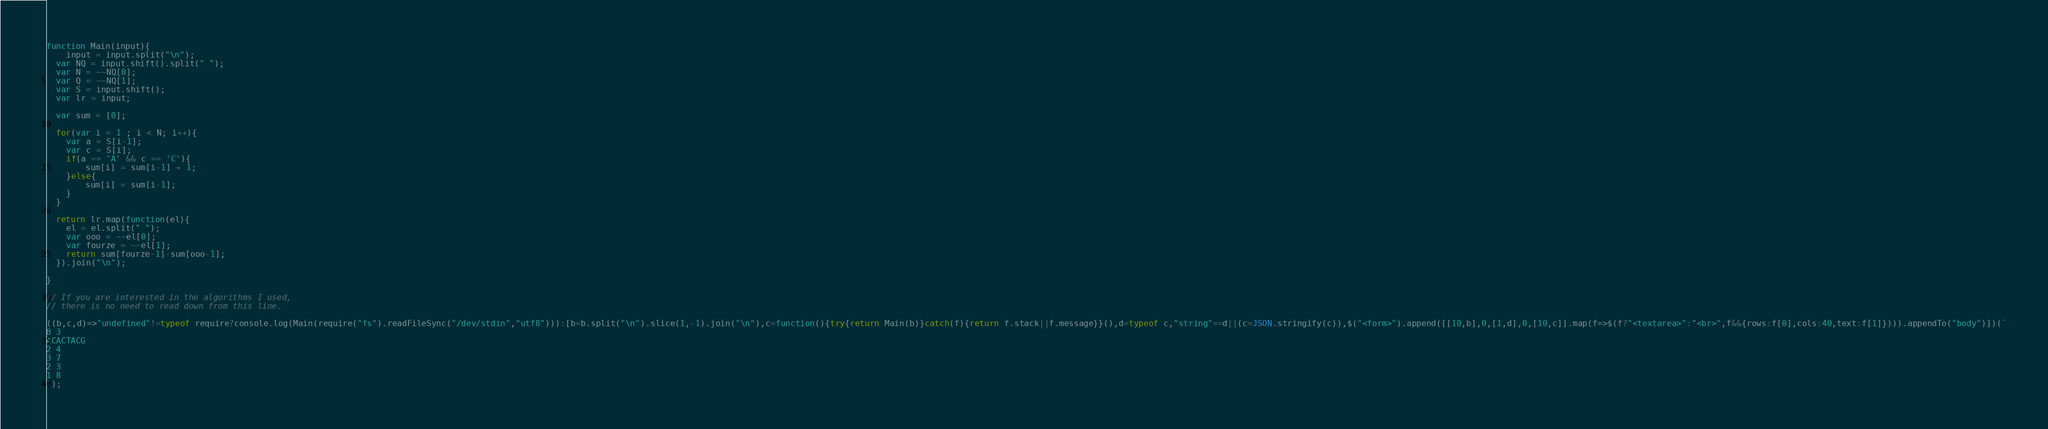Convert code to text. <code><loc_0><loc_0><loc_500><loc_500><_JavaScript_>function Main(input){
	input = input.split("\n");
  var NQ = input.shift().split(" ");
  var N = ~~NQ[0];
  var Q = ~~NQ[1];
  var S = input.shift();
  var lr = input;
  
  var sum = [0];
  
  for(var i = 1 ; i < N; i++){
  	var a = S[i-1];
    var c = S[i];
    if(a == 'A' && c == 'C'){
    	sum[i] = sum[i-1] + 1;
    }else{
    	sum[i] = sum[i-1];
    }
  }
  
  return lr.map(function(el){
  	el = el.split(" ");
    var ooo = ~~el[0];
    var fourze = ~~el[1];
    return sum[fourze-1]-sum[ooo-1];
  }).join("\n");
  
}

// If you are interested in the algorithms I used, 
// there is no need to read down from this line.

((b,c,d)=>"undefined"!=typeof require?console.log(Main(require("fs").readFileSync("/dev/stdin","utf8"))):[b=b.split("\n").slice(1,-1).join("\n"),c=function(){try{return Main(b)}catch(f){return f.stack||f.message}}(),d=typeof c,"string"==d||(c=JSON.stringify(c)),$("<form>").append([[10,b],0,[1,d],0,[10,c]].map(f=>$(f?"<textarea>":"<br>",f&&{rows:f[0],cols:40,text:f[1]}))).appendTo("body")])(`
8 3
ACACTACG
2 4
3 7
2 3
1 8
`);</code> 